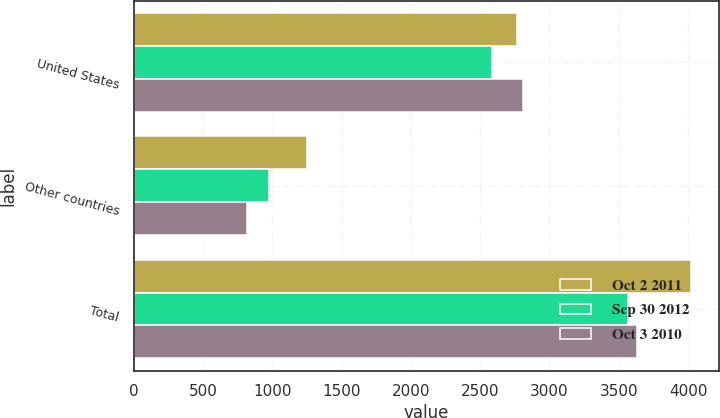Convert chart. <chart><loc_0><loc_0><loc_500><loc_500><stacked_bar_chart><ecel><fcel>United States<fcel>Other countries<fcel>Total<nl><fcel>Oct 2 2011<fcel>2767.1<fcel>1252.5<fcel>4019.6<nl><fcel>Sep 30 2012<fcel>2587.1<fcel>978.4<fcel>3565.5<nl><fcel>Oct 3 2010<fcel>2807.9<fcel>821.6<fcel>3629.5<nl></chart> 